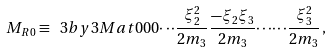Convert formula to latex. <formula><loc_0><loc_0><loc_500><loc_500>M _ { R 0 } \equiv \ 3 b y 3 M a t { 0 } { 0 } { 0 } { \cdots } { \frac { \xi _ { 2 } ^ { 2 } } { 2 m _ { 3 } } } { \frac { - \xi _ { 2 } \xi _ { 3 } } { 2 m _ { 3 } } } { \cdots } { \cdots } { \frac { \xi _ { 3 } ^ { 2 } } { 2 m _ { 3 } } } \, ,</formula> 